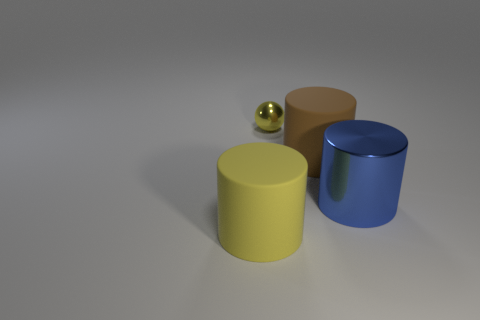Add 2 small yellow metallic objects. How many objects exist? 6 Subtract all spheres. How many objects are left? 3 Add 3 small yellow balls. How many small yellow balls are left? 4 Add 1 red matte cylinders. How many red matte cylinders exist? 1 Subtract 0 brown spheres. How many objects are left? 4 Subtract all big brown rubber things. Subtract all brown matte things. How many objects are left? 2 